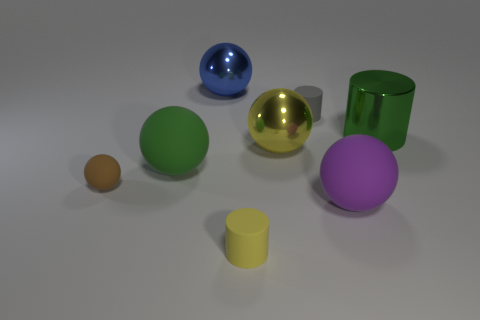There is a tiny brown object; how many matte cylinders are behind it?
Make the answer very short. 1. Is the number of tiny green metallic balls less than the number of yellow things?
Your response must be concise. Yes. There is a shiny thing that is both on the left side of the large green cylinder and in front of the tiny gray matte cylinder; what is its size?
Keep it short and to the point. Large. There is a matte cylinder behind the brown sphere; is its color the same as the large metal cylinder?
Your answer should be compact. No. Are there fewer purple matte spheres behind the large green cylinder than gray objects?
Offer a terse response. Yes. There is a blue thing that is the same material as the big yellow sphere; what shape is it?
Ensure brevity in your answer.  Sphere. Does the gray object have the same material as the tiny brown ball?
Keep it short and to the point. Yes. Is the number of gray rubber cylinders that are in front of the small brown rubber object less than the number of big purple matte things that are behind the blue shiny object?
Provide a short and direct response. No. There is a matte sphere that is the same color as the metallic cylinder; what is its size?
Your response must be concise. Large. How many gray rubber things are behind the small rubber object that is on the right side of the small cylinder left of the small gray thing?
Your response must be concise. 0. 